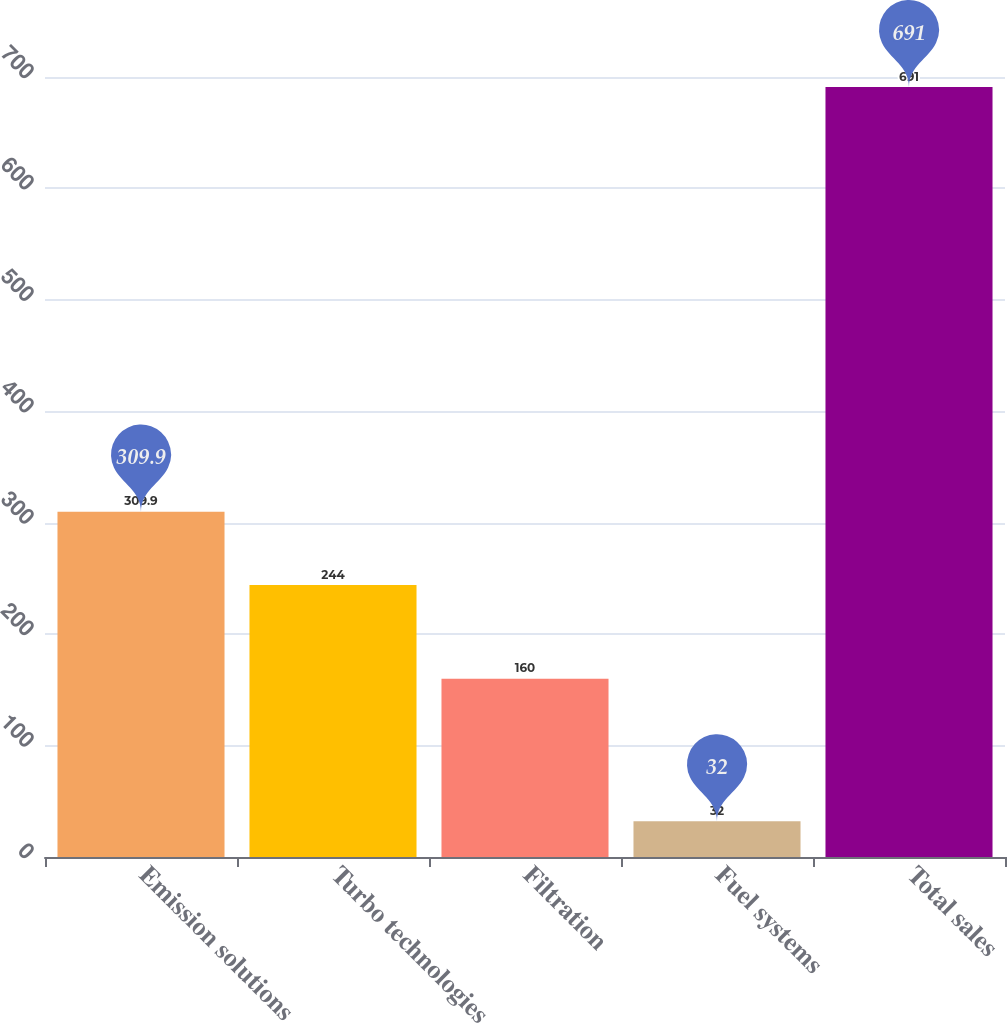Convert chart to OTSL. <chart><loc_0><loc_0><loc_500><loc_500><bar_chart><fcel>Emission solutions<fcel>Turbo technologies<fcel>Filtration<fcel>Fuel systems<fcel>Total sales<nl><fcel>309.9<fcel>244<fcel>160<fcel>32<fcel>691<nl></chart> 